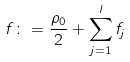<formula> <loc_0><loc_0><loc_500><loc_500>f \colon = \frac { \rho _ { 0 } } { 2 } + \sum _ { j = 1 } ^ { l } f _ { j }</formula> 